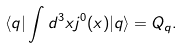<formula> <loc_0><loc_0><loc_500><loc_500>\langle q | \int d ^ { 3 } x j ^ { 0 } ( x ) | q \rangle = Q _ { q } .</formula> 